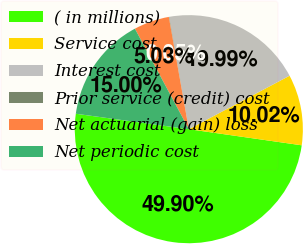Convert chart. <chart><loc_0><loc_0><loc_500><loc_500><pie_chart><fcel>( in millions)<fcel>Service cost<fcel>Interest cost<fcel>Prior service (credit) cost<fcel>Net actuarial (gain) loss<fcel>Net periodic cost<nl><fcel>49.9%<fcel>10.02%<fcel>19.99%<fcel>0.05%<fcel>5.03%<fcel>15.0%<nl></chart> 